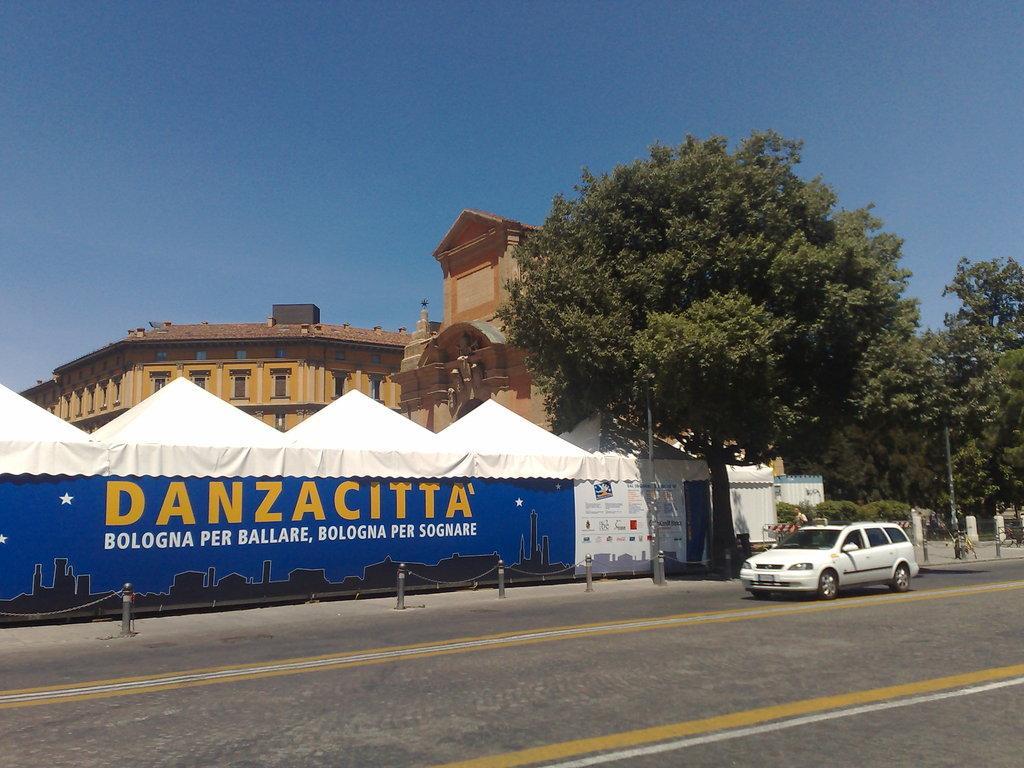Can you describe this image briefly? In this image I can see the road. On the road there is a white color car. To the side of the car I can see the tents and there is a board to the tents. In the background I can see the trees, building and the blue sky. 